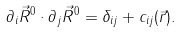Convert formula to latex. <formula><loc_0><loc_0><loc_500><loc_500>\partial _ { i } \vec { R } ^ { 0 } \cdot \partial _ { j } \vec { R } ^ { 0 } = \delta _ { i j } + c _ { i j } ( \vec { r } ) .</formula> 